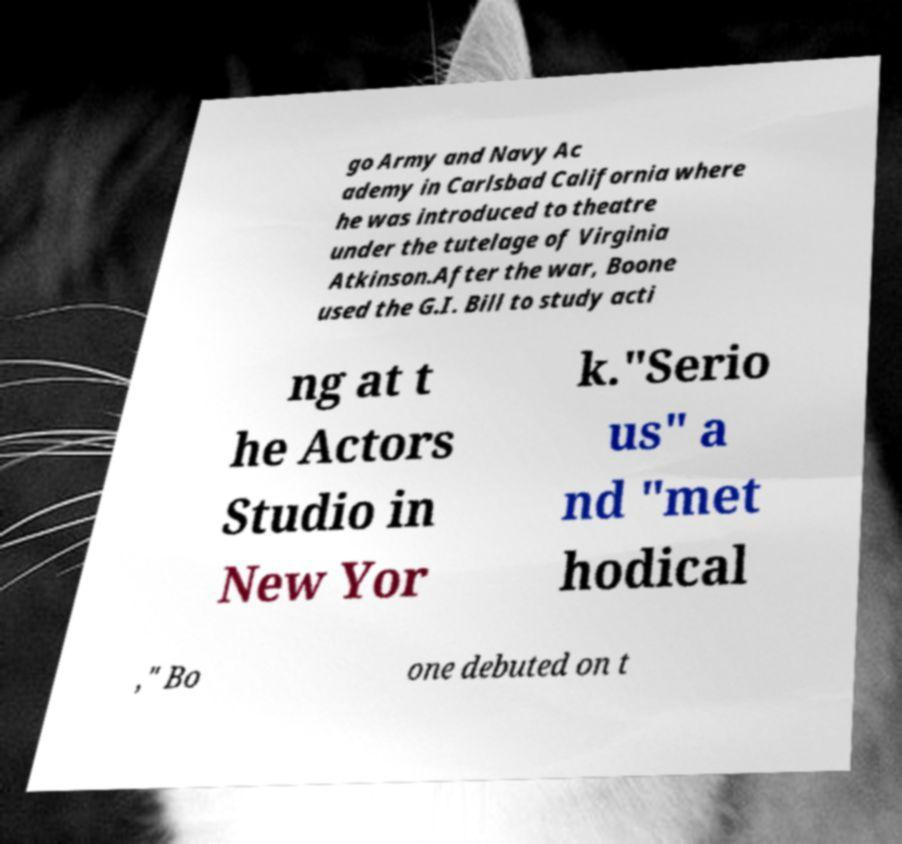Please read and relay the text visible in this image. What does it say? go Army and Navy Ac ademy in Carlsbad California where he was introduced to theatre under the tutelage of Virginia Atkinson.After the war, Boone used the G.I. Bill to study acti ng at t he Actors Studio in New Yor k."Serio us" a nd "met hodical ," Bo one debuted on t 